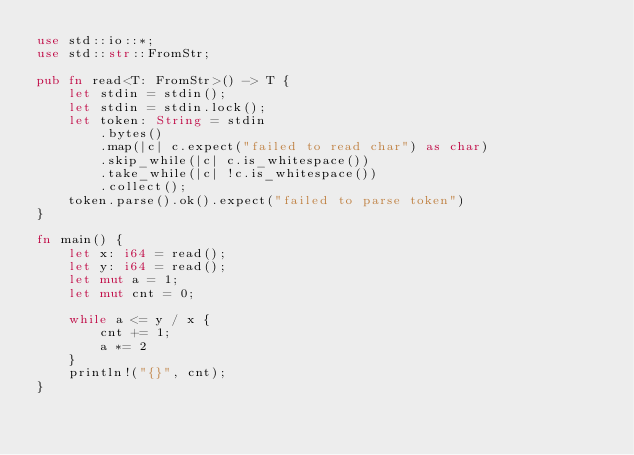Convert code to text. <code><loc_0><loc_0><loc_500><loc_500><_Rust_>use std::io::*;
use std::str::FromStr;

pub fn read<T: FromStr>() -> T {
    let stdin = stdin();
    let stdin = stdin.lock();
    let token: String = stdin
        .bytes()
        .map(|c| c.expect("failed to read char") as char)
        .skip_while(|c| c.is_whitespace())
        .take_while(|c| !c.is_whitespace())
        .collect();
    token.parse().ok().expect("failed to parse token")
}

fn main() {
    let x: i64 = read();
    let y: i64 = read();
    let mut a = 1;
    let mut cnt = 0;

    while a <= y / x {
        cnt += 1;
        a *= 2
    }
    println!("{}", cnt);
}
</code> 